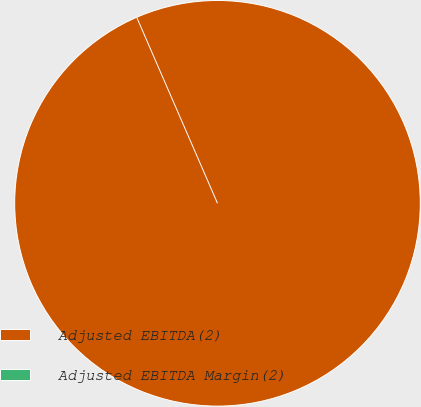<chart> <loc_0><loc_0><loc_500><loc_500><pie_chart><fcel>Adjusted EBITDA(2)<fcel>Adjusted EBITDA Margin(2)<nl><fcel>100.0%<fcel>0.0%<nl></chart> 